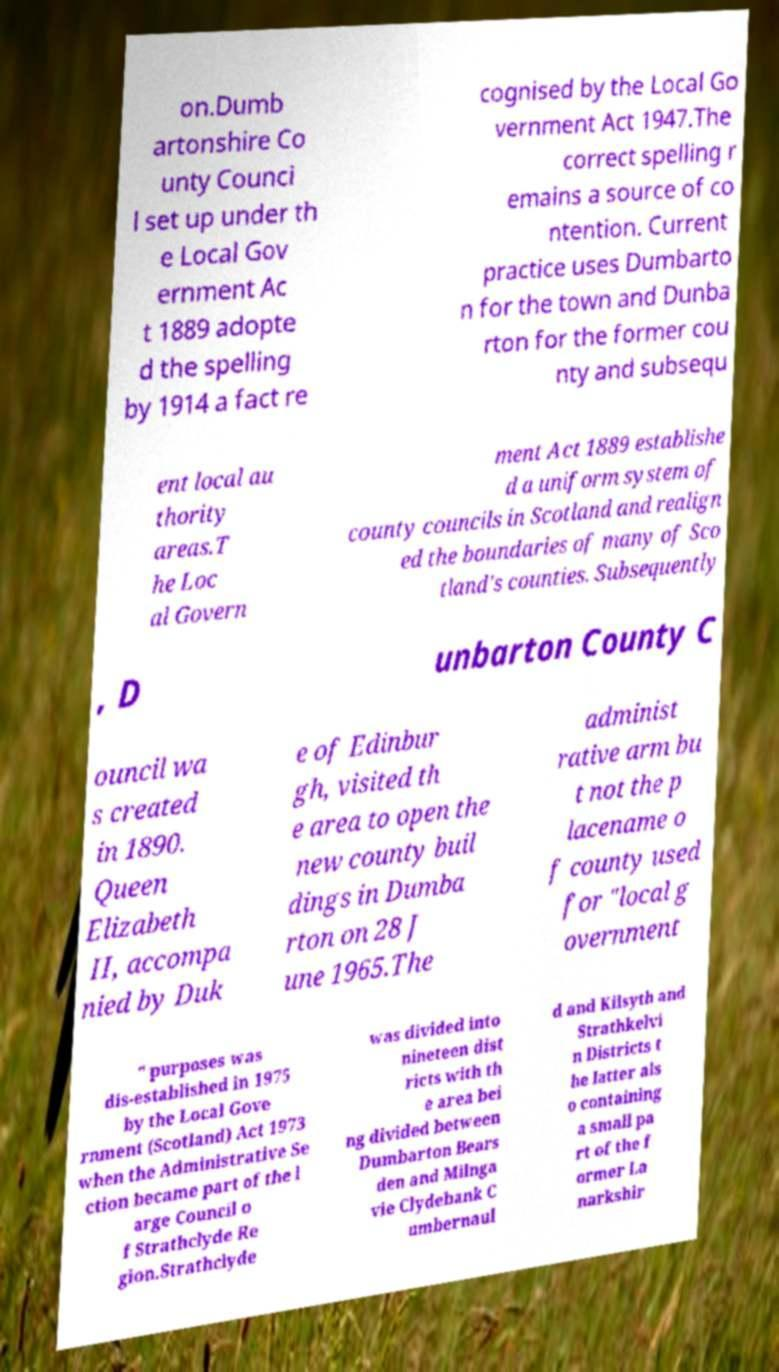Please read and relay the text visible in this image. What does it say? on.Dumb artonshire Co unty Counci l set up under th e Local Gov ernment Ac t 1889 adopte d the spelling by 1914 a fact re cognised by the Local Go vernment Act 1947.The correct spelling r emains a source of co ntention. Current practice uses Dumbarto n for the town and Dunba rton for the former cou nty and subsequ ent local au thority areas.T he Loc al Govern ment Act 1889 establishe d a uniform system of county councils in Scotland and realign ed the boundaries of many of Sco tland's counties. Subsequently , D unbarton County C ouncil wa s created in 1890. Queen Elizabeth II, accompa nied by Duk e of Edinbur gh, visited th e area to open the new county buil dings in Dumba rton on 28 J une 1965.The administ rative arm bu t not the p lacename o f county used for "local g overnment " purposes was dis-established in 1975 by the Local Gove rnment (Scotland) Act 1973 when the Administrative Se ction became part of the l arge Council o f Strathclyde Re gion.Strathclyde was divided into nineteen dist ricts with th e area bei ng divided between Dumbarton Bears den and Milnga vie Clydebank C umbernaul d and Kilsyth and Strathkelvi n Districts t he latter als o containing a small pa rt of the f ormer La narkshir 